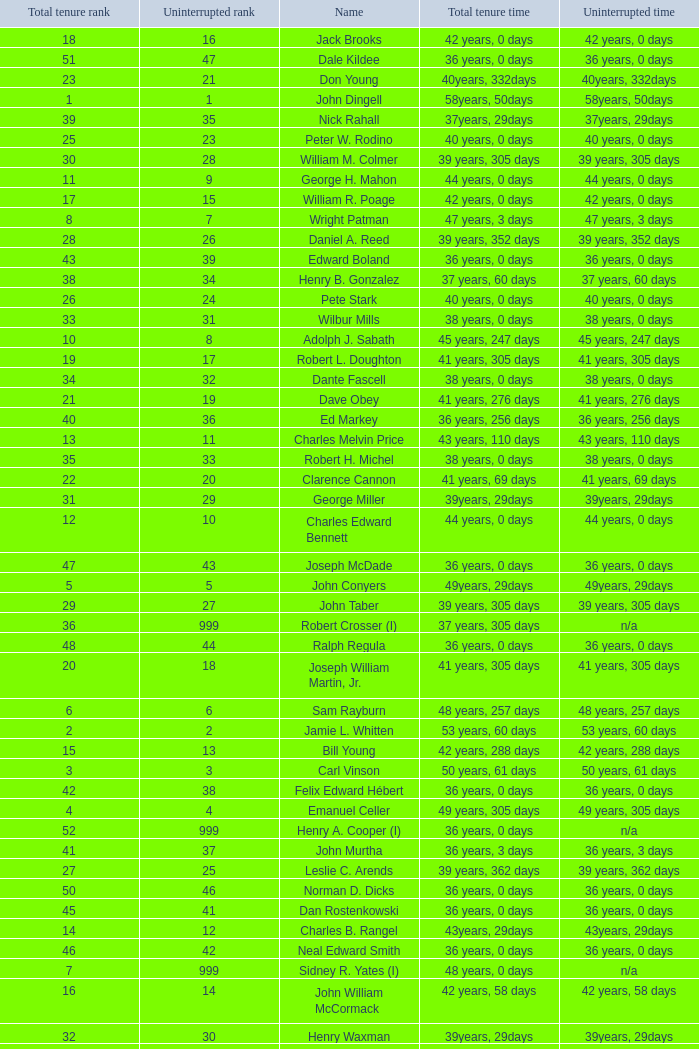Who has a total tenure time and uninterrupted time of 36 years, 0 days, as well as a total tenure rank of 49? James Oberstar. 